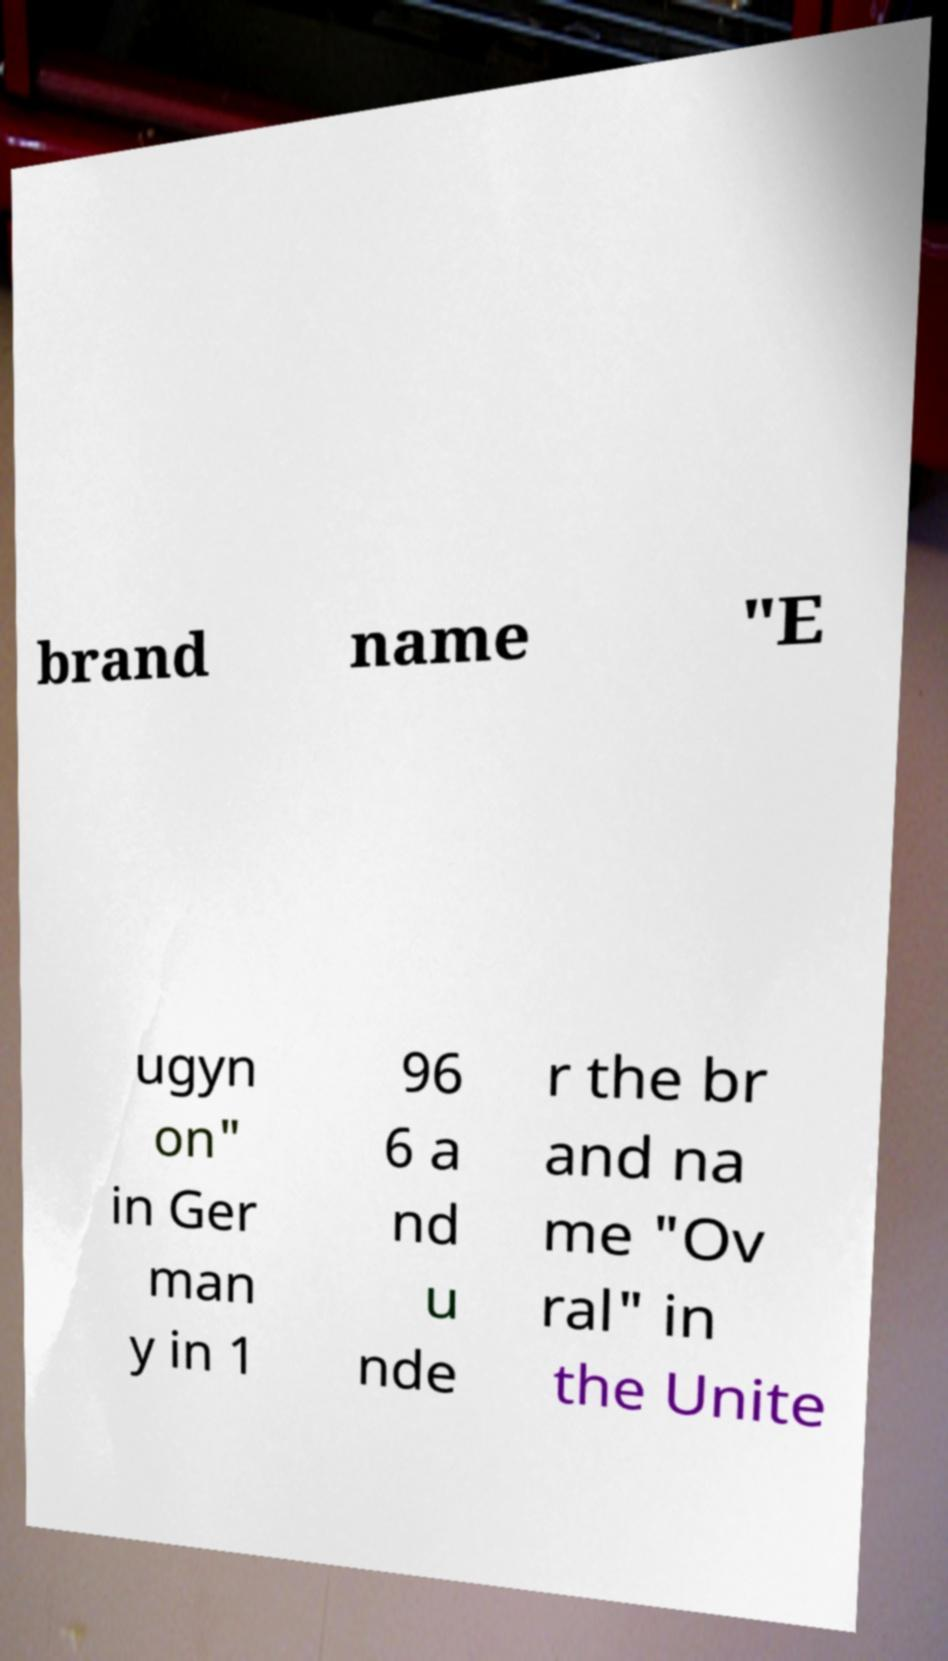Could you extract and type out the text from this image? brand name "E ugyn on" in Ger man y in 1 96 6 a nd u nde r the br and na me "Ov ral" in the Unite 